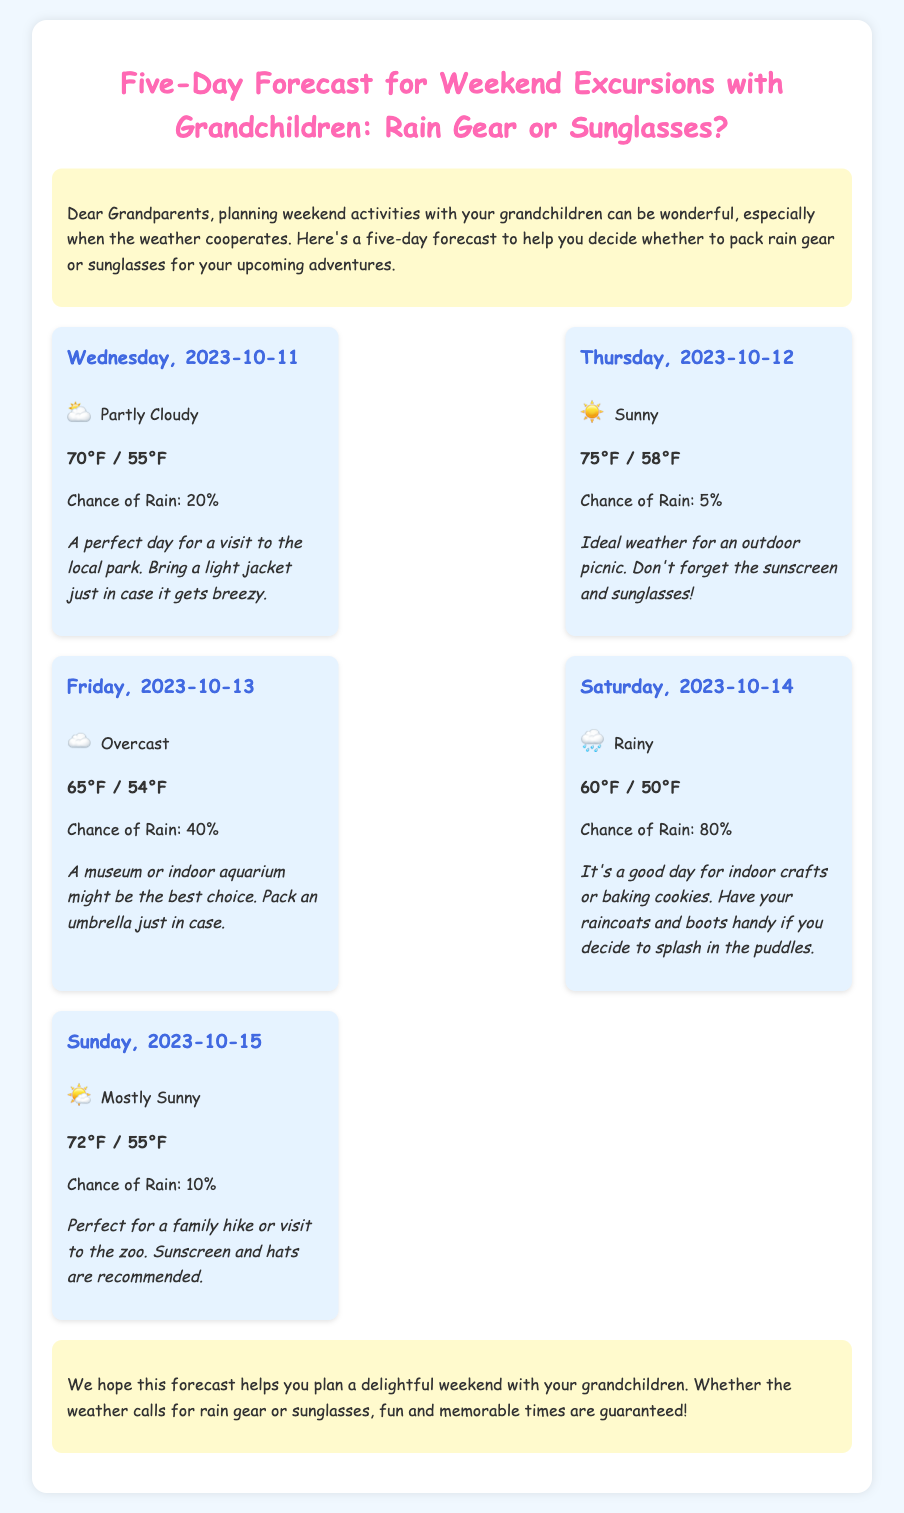What is the weather forecast for Saturday? The document states that Saturday's forecast is "Rainy."
Answer: Rainy What is the temperature range on Thursday? The temperature range for Thursday is given as "75°F / 58°F."
Answer: 75°F / 58°F What is the chance of rain on Friday? The chance of rain on Friday is stated as "40%."
Answer: 40% What activities are suggested for a rainy Saturday? The document advises that Saturday is good for "indoor crafts or baking cookies."
Answer: indoor crafts or baking cookies What item should be packed for Friday's forecast? The forecast for Friday suggests packing an "umbrella."
Answer: umbrella 